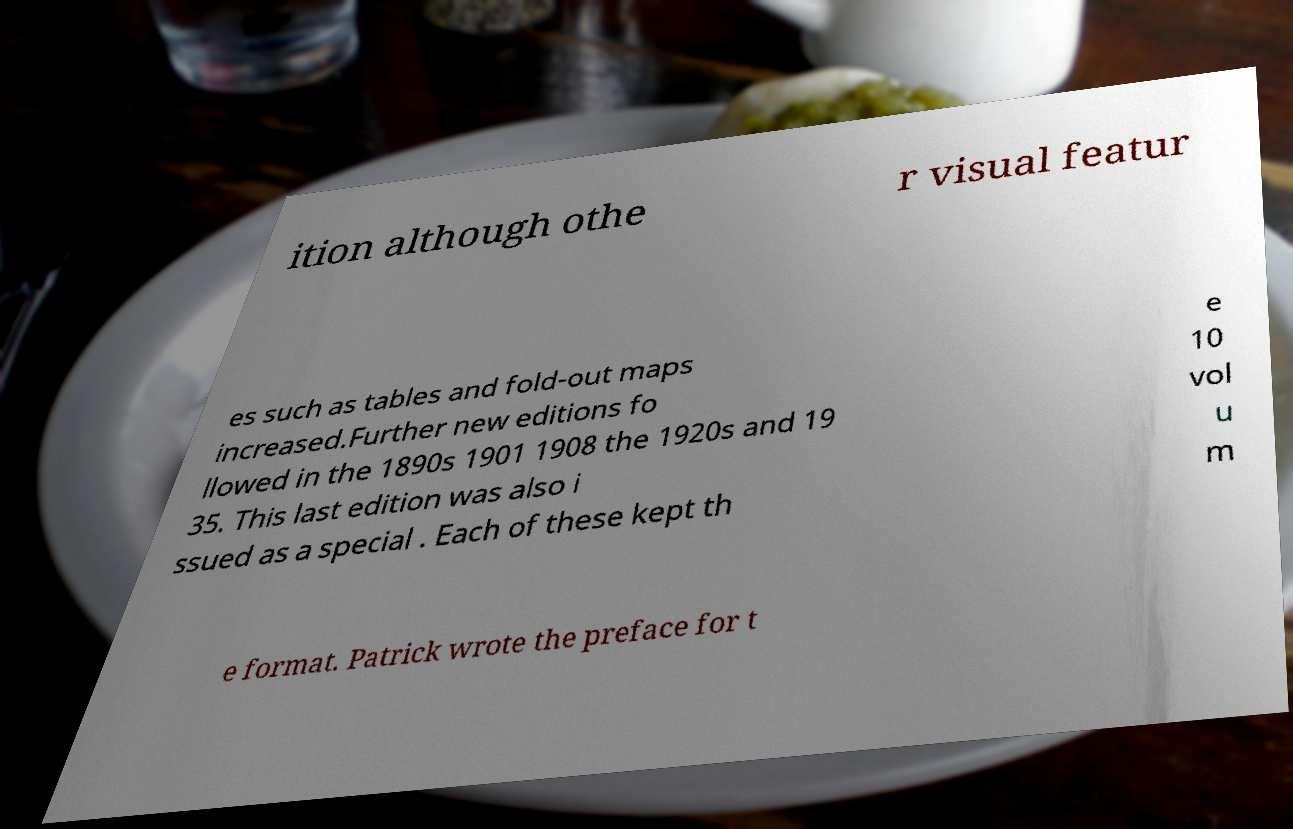There's text embedded in this image that I need extracted. Can you transcribe it verbatim? ition although othe r visual featur es such as tables and fold-out maps increased.Further new editions fo llowed in the 1890s 1901 1908 the 1920s and 19 35. This last edition was also i ssued as a special . Each of these kept th e 10 vol u m e format. Patrick wrote the preface for t 